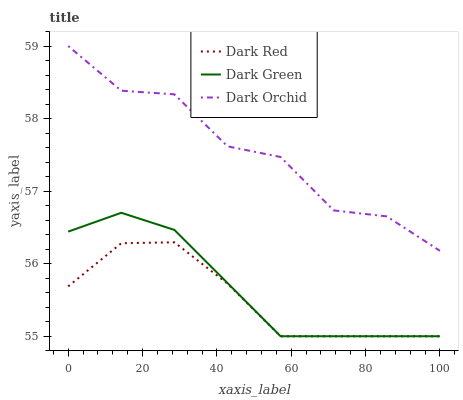Does Dark Red have the minimum area under the curve?
Answer yes or no. Yes. Does Dark Orchid have the maximum area under the curve?
Answer yes or no. Yes. Does Dark Green have the minimum area under the curve?
Answer yes or no. No. Does Dark Green have the maximum area under the curve?
Answer yes or no. No. Is Dark Green the smoothest?
Answer yes or no. Yes. Is Dark Orchid the roughest?
Answer yes or no. Yes. Is Dark Orchid the smoothest?
Answer yes or no. No. Is Dark Green the roughest?
Answer yes or no. No. Does Dark Red have the lowest value?
Answer yes or no. Yes. Does Dark Orchid have the lowest value?
Answer yes or no. No. Does Dark Orchid have the highest value?
Answer yes or no. Yes. Does Dark Green have the highest value?
Answer yes or no. No. Is Dark Red less than Dark Orchid?
Answer yes or no. Yes. Is Dark Orchid greater than Dark Red?
Answer yes or no. Yes. Does Dark Red intersect Dark Green?
Answer yes or no. Yes. Is Dark Red less than Dark Green?
Answer yes or no. No. Is Dark Red greater than Dark Green?
Answer yes or no. No. Does Dark Red intersect Dark Orchid?
Answer yes or no. No. 